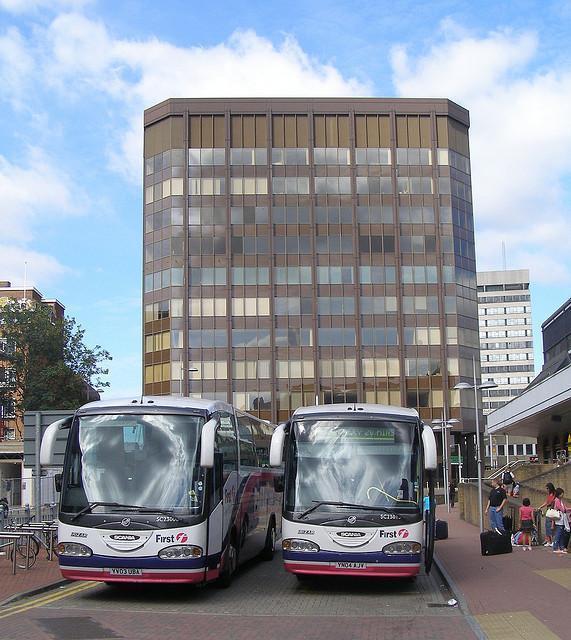How many buses are in the picture?
Give a very brief answer. 2. How many buses are there?
Give a very brief answer. 2. How many horse riders?
Give a very brief answer. 0. 